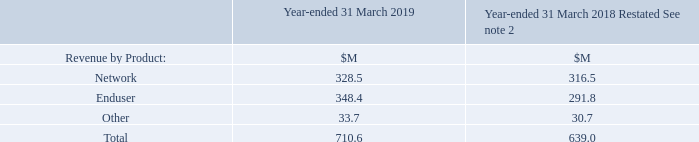7 Revenue
Revenue recognised in the Consolidated Statement of Profit or Loss is analysed as follows:
What was the amount of Total revenue in 2019?
Answer scale should be: million. 710.6. What was the amount of Other in 2019?
Answer scale should be: million. 33.7. What are the product types analyzed in the table which contribute to the Revenue recognised in the Consolidated Statement of Profit or Loss? Network, enduser, other. In which year was the amount of Other larger? 33.7>30.7
Answer: 2019. What was the change in Enduser in 2019 from 2018?
Answer scale should be: million. 348.4-291.8
Answer: 56.6. What was the percentage change in Enduser in 2019 from 2018?
Answer scale should be: percent. (348.4-291.8)/291.8
Answer: 19.4. 